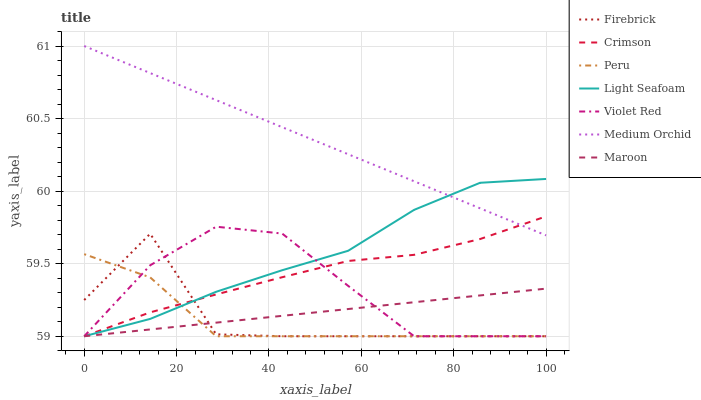Does Peru have the minimum area under the curve?
Answer yes or no. Yes. Does Medium Orchid have the maximum area under the curve?
Answer yes or no. Yes. Does Firebrick have the minimum area under the curve?
Answer yes or no. No. Does Firebrick have the maximum area under the curve?
Answer yes or no. No. Is Medium Orchid the smoothest?
Answer yes or no. Yes. Is Firebrick the roughest?
Answer yes or no. Yes. Is Firebrick the smoothest?
Answer yes or no. No. Is Medium Orchid the roughest?
Answer yes or no. No. Does Medium Orchid have the lowest value?
Answer yes or no. No. Does Medium Orchid have the highest value?
Answer yes or no. Yes. Does Firebrick have the highest value?
Answer yes or no. No. Is Firebrick less than Medium Orchid?
Answer yes or no. Yes. Is Medium Orchid greater than Violet Red?
Answer yes or no. Yes. Does Firebrick intersect Light Seafoam?
Answer yes or no. Yes. Is Firebrick less than Light Seafoam?
Answer yes or no. No. Is Firebrick greater than Light Seafoam?
Answer yes or no. No. Does Firebrick intersect Medium Orchid?
Answer yes or no. No. 